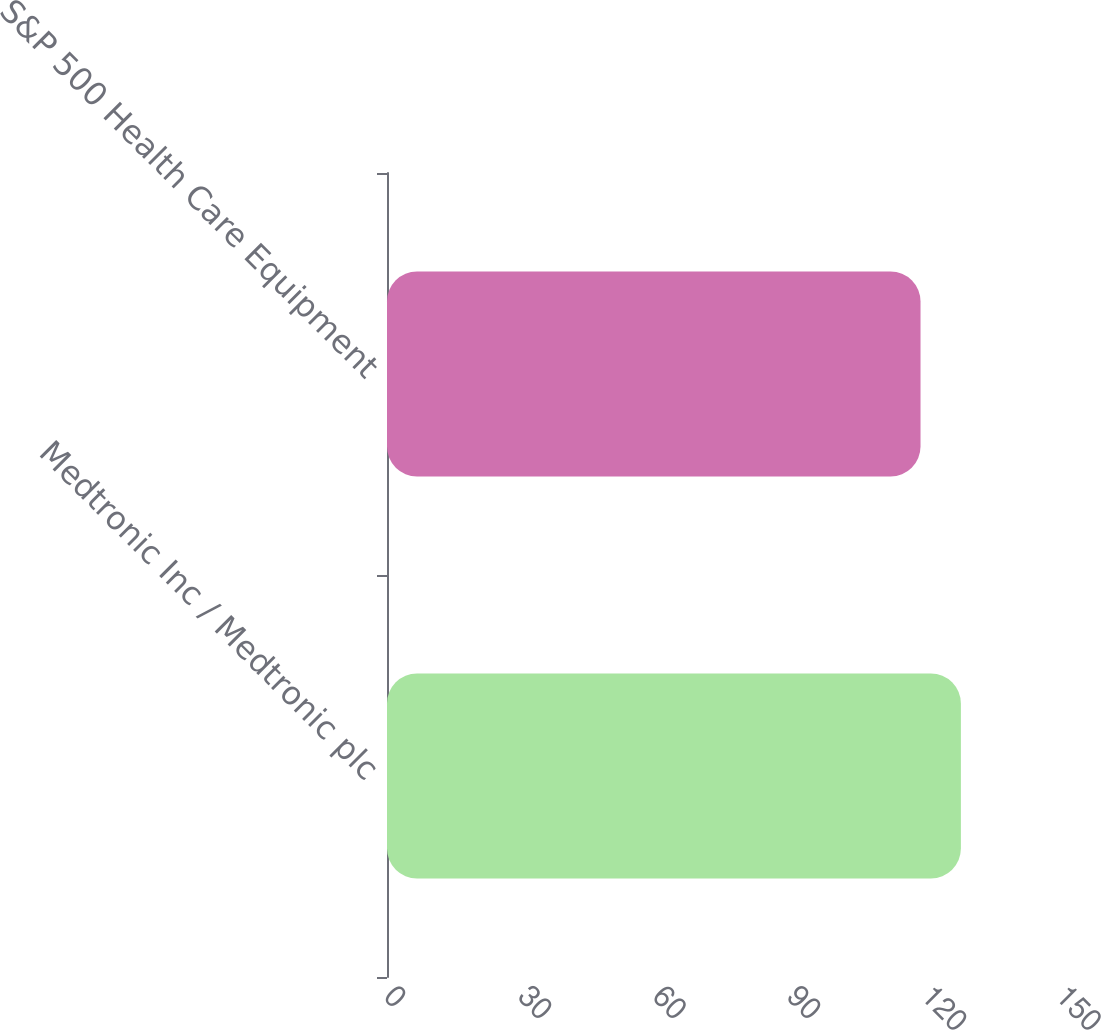<chart> <loc_0><loc_0><loc_500><loc_500><bar_chart><fcel>Medtronic Inc / Medtronic plc<fcel>S&P 500 Health Care Equipment<nl><fcel>128.1<fcel>119.09<nl></chart> 